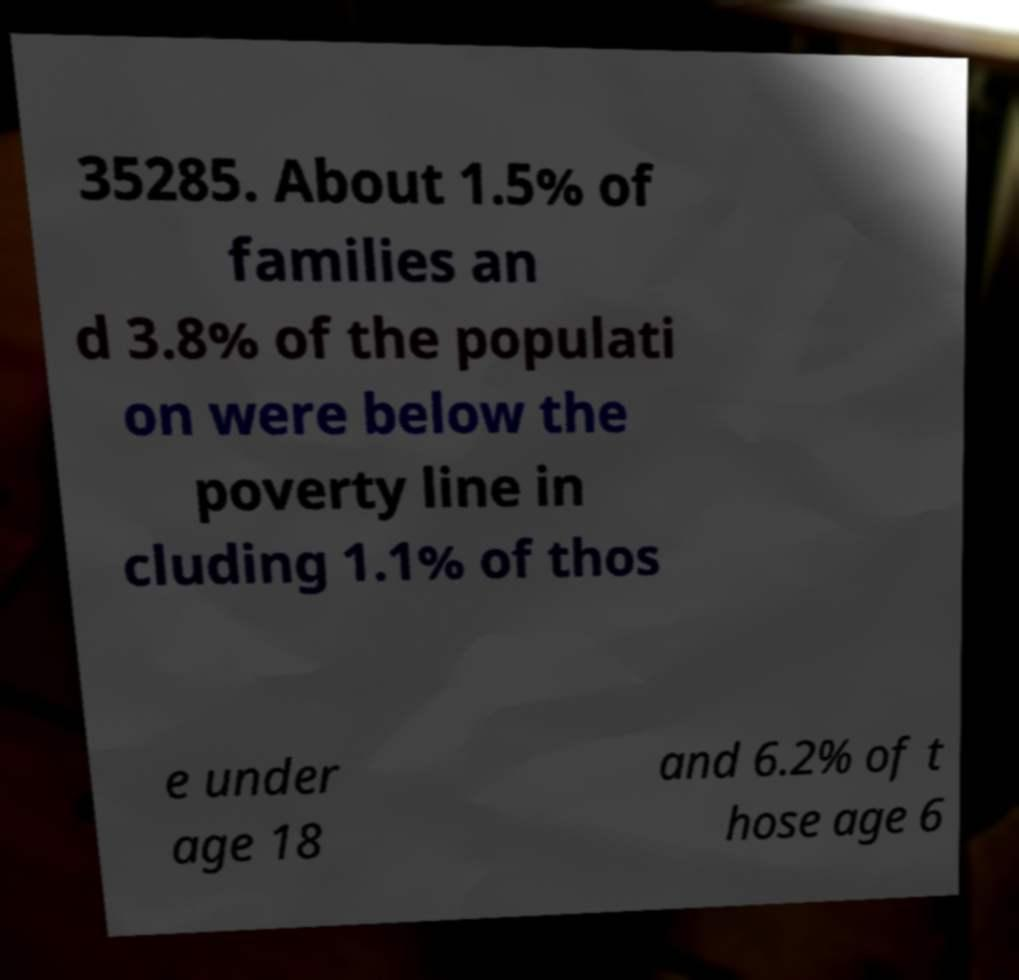Could you assist in decoding the text presented in this image and type it out clearly? 35285. About 1.5% of families an d 3.8% of the populati on were below the poverty line in cluding 1.1% of thos e under age 18 and 6.2% of t hose age 6 